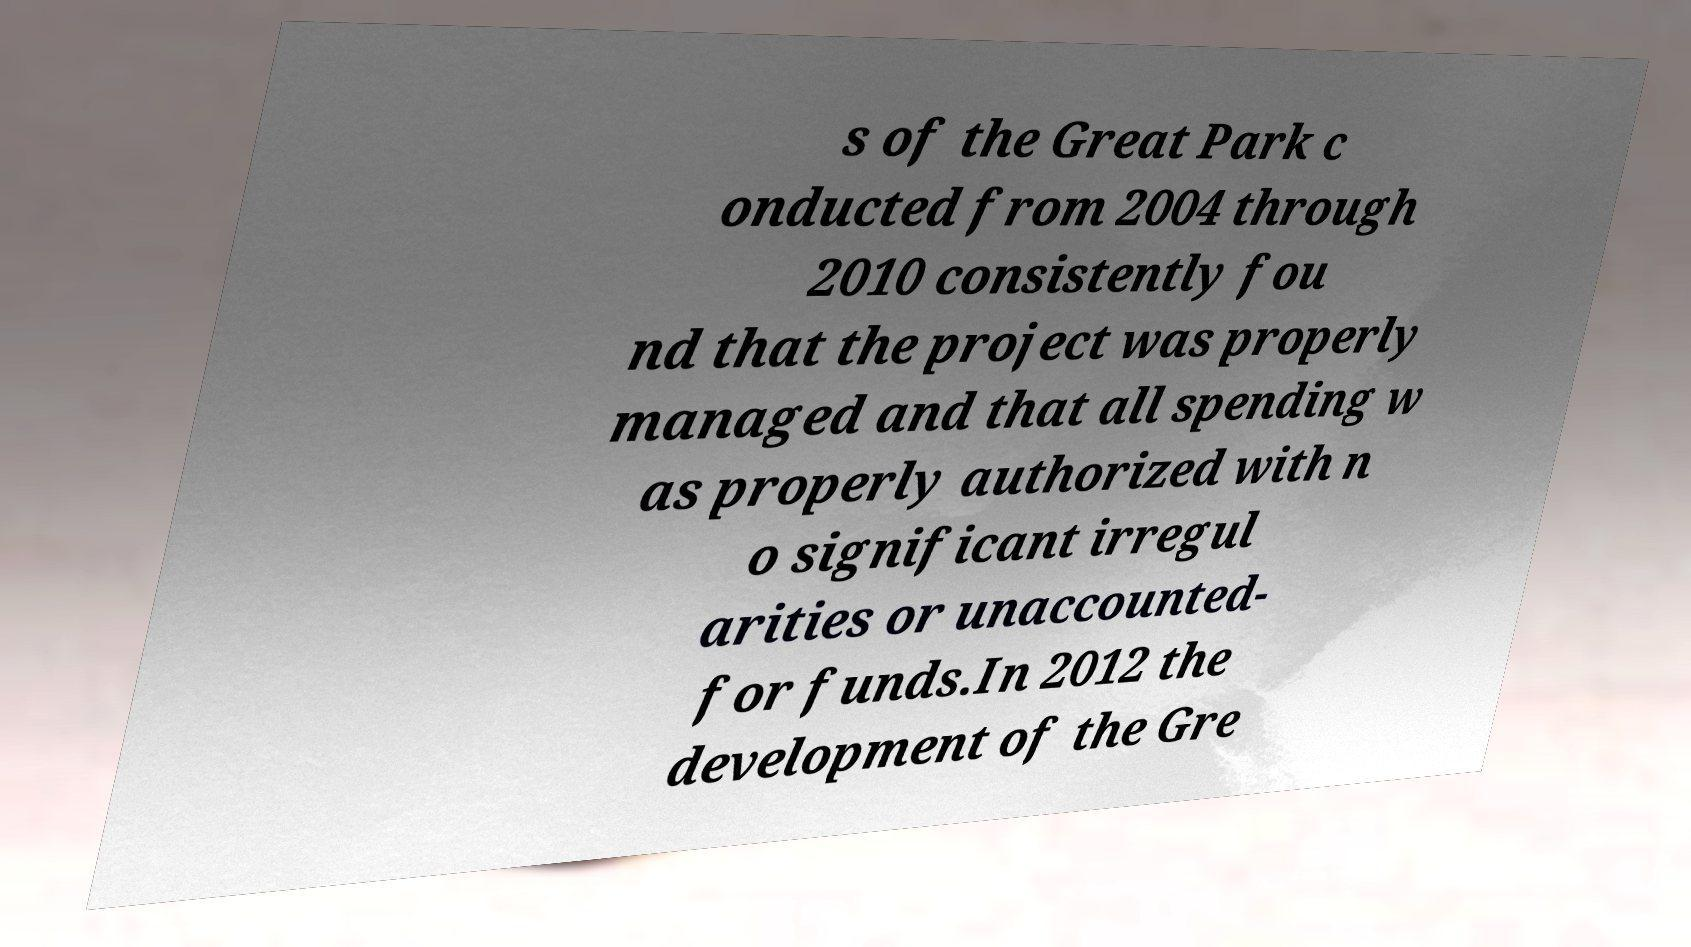For documentation purposes, I need the text within this image transcribed. Could you provide that? s of the Great Park c onducted from 2004 through 2010 consistently fou nd that the project was properly managed and that all spending w as properly authorized with n o significant irregul arities or unaccounted- for funds.In 2012 the development of the Gre 